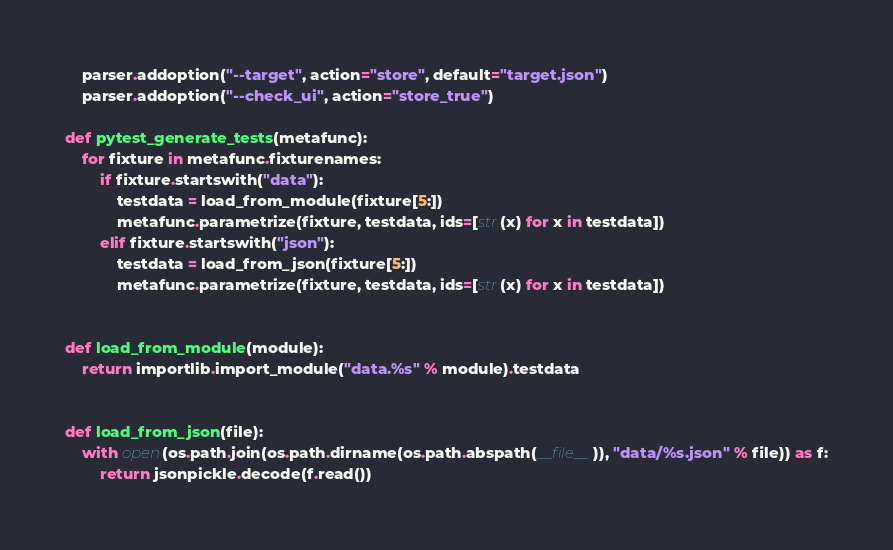<code> <loc_0><loc_0><loc_500><loc_500><_Python_>    parser.addoption("--target", action="store", default="target.json")
    parser.addoption("--check_ui", action="store_true")

def pytest_generate_tests(metafunc):
    for fixture in metafunc.fixturenames:
        if fixture.startswith("data"):
            testdata = load_from_module(fixture[5:])
            metafunc.parametrize(fixture, testdata, ids=[str(x) for x in testdata])
        elif fixture.startswith("json"):
            testdata = load_from_json(fixture[5:])
            metafunc.parametrize(fixture, testdata, ids=[str(x) for x in testdata])


def load_from_module(module):
    return importlib.import_module("data.%s" % module).testdata


def load_from_json(file):
    with open(os.path.join(os.path.dirname(os.path.abspath(__file__)), "data/%s.json" % file)) as f:
        return jsonpickle.decode(f.read())</code> 